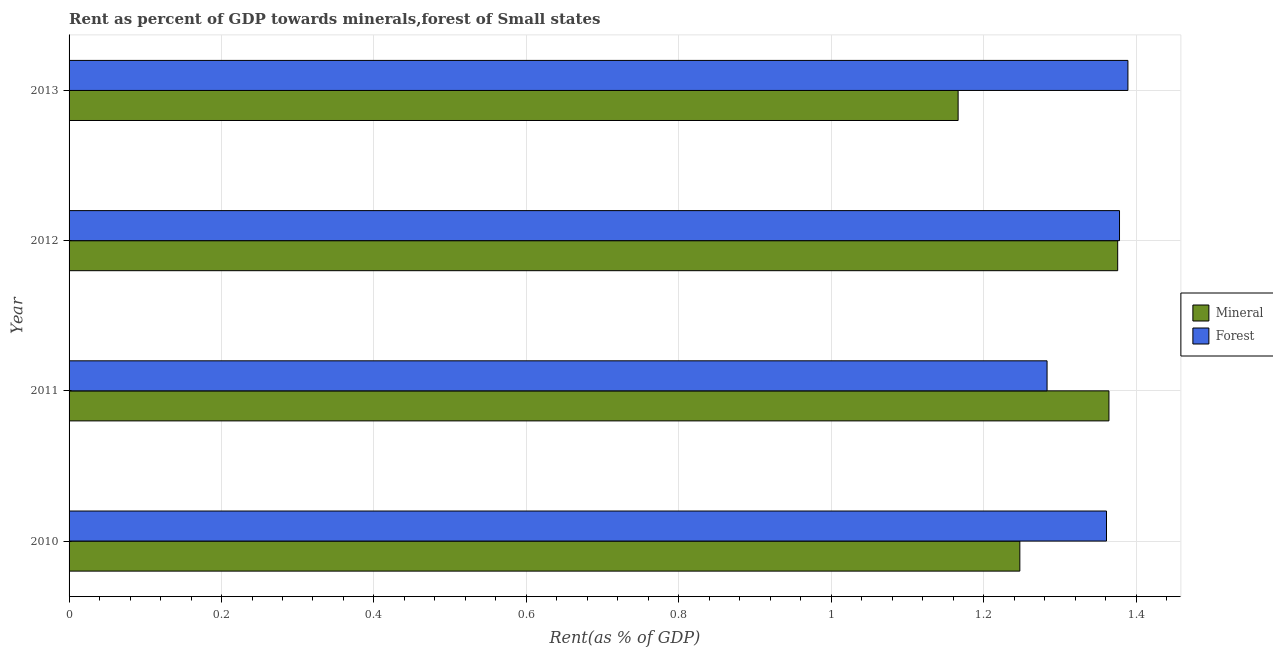How many different coloured bars are there?
Provide a succinct answer. 2. Are the number of bars per tick equal to the number of legend labels?
Your answer should be very brief. Yes. Are the number of bars on each tick of the Y-axis equal?
Ensure brevity in your answer.  Yes. How many bars are there on the 3rd tick from the top?
Your answer should be compact. 2. How many bars are there on the 1st tick from the bottom?
Your answer should be very brief. 2. In how many cases, is the number of bars for a given year not equal to the number of legend labels?
Make the answer very short. 0. What is the forest rent in 2013?
Keep it short and to the point. 1.39. Across all years, what is the maximum mineral rent?
Your answer should be compact. 1.38. Across all years, what is the minimum forest rent?
Ensure brevity in your answer.  1.28. In which year was the mineral rent maximum?
Your response must be concise. 2012. In which year was the forest rent minimum?
Keep it short and to the point. 2011. What is the total mineral rent in the graph?
Keep it short and to the point. 5.15. What is the difference between the mineral rent in 2010 and that in 2012?
Offer a terse response. -0.13. What is the difference between the forest rent in 2011 and the mineral rent in 2010?
Your answer should be compact. 0.04. What is the average forest rent per year?
Offer a terse response. 1.35. In the year 2010, what is the difference between the forest rent and mineral rent?
Keep it short and to the point. 0.11. Is the forest rent in 2010 less than that in 2012?
Provide a succinct answer. Yes. What is the difference between the highest and the second highest mineral rent?
Ensure brevity in your answer.  0.01. What is the difference between the highest and the lowest forest rent?
Make the answer very short. 0.11. What does the 1st bar from the top in 2010 represents?
Your answer should be compact. Forest. What does the 2nd bar from the bottom in 2012 represents?
Offer a very short reply. Forest. Are all the bars in the graph horizontal?
Give a very brief answer. Yes. How many years are there in the graph?
Your response must be concise. 4. Does the graph contain any zero values?
Give a very brief answer. No. Does the graph contain grids?
Make the answer very short. Yes. Where does the legend appear in the graph?
Provide a short and direct response. Center right. How many legend labels are there?
Provide a succinct answer. 2. What is the title of the graph?
Make the answer very short. Rent as percent of GDP towards minerals,forest of Small states. Does "Females" appear as one of the legend labels in the graph?
Your response must be concise. No. What is the label or title of the X-axis?
Offer a terse response. Rent(as % of GDP). What is the Rent(as % of GDP) of Mineral in 2010?
Make the answer very short. 1.25. What is the Rent(as % of GDP) of Forest in 2010?
Ensure brevity in your answer.  1.36. What is the Rent(as % of GDP) of Mineral in 2011?
Keep it short and to the point. 1.36. What is the Rent(as % of GDP) in Forest in 2011?
Your answer should be very brief. 1.28. What is the Rent(as % of GDP) in Mineral in 2012?
Make the answer very short. 1.38. What is the Rent(as % of GDP) in Forest in 2012?
Your response must be concise. 1.38. What is the Rent(as % of GDP) in Mineral in 2013?
Give a very brief answer. 1.17. What is the Rent(as % of GDP) in Forest in 2013?
Your answer should be very brief. 1.39. Across all years, what is the maximum Rent(as % of GDP) in Mineral?
Provide a succinct answer. 1.38. Across all years, what is the maximum Rent(as % of GDP) in Forest?
Your response must be concise. 1.39. Across all years, what is the minimum Rent(as % of GDP) of Mineral?
Keep it short and to the point. 1.17. Across all years, what is the minimum Rent(as % of GDP) of Forest?
Offer a very short reply. 1.28. What is the total Rent(as % of GDP) in Mineral in the graph?
Offer a very short reply. 5.15. What is the total Rent(as % of GDP) of Forest in the graph?
Give a very brief answer. 5.41. What is the difference between the Rent(as % of GDP) in Mineral in 2010 and that in 2011?
Offer a terse response. -0.12. What is the difference between the Rent(as % of GDP) of Forest in 2010 and that in 2011?
Your response must be concise. 0.08. What is the difference between the Rent(as % of GDP) of Mineral in 2010 and that in 2012?
Ensure brevity in your answer.  -0.13. What is the difference between the Rent(as % of GDP) of Forest in 2010 and that in 2012?
Give a very brief answer. -0.02. What is the difference between the Rent(as % of GDP) of Mineral in 2010 and that in 2013?
Your answer should be very brief. 0.08. What is the difference between the Rent(as % of GDP) in Forest in 2010 and that in 2013?
Keep it short and to the point. -0.03. What is the difference between the Rent(as % of GDP) in Mineral in 2011 and that in 2012?
Offer a very short reply. -0.01. What is the difference between the Rent(as % of GDP) of Forest in 2011 and that in 2012?
Provide a succinct answer. -0.1. What is the difference between the Rent(as % of GDP) of Mineral in 2011 and that in 2013?
Ensure brevity in your answer.  0.2. What is the difference between the Rent(as % of GDP) in Forest in 2011 and that in 2013?
Make the answer very short. -0.11. What is the difference between the Rent(as % of GDP) in Mineral in 2012 and that in 2013?
Make the answer very short. 0.21. What is the difference between the Rent(as % of GDP) of Forest in 2012 and that in 2013?
Make the answer very short. -0.01. What is the difference between the Rent(as % of GDP) in Mineral in 2010 and the Rent(as % of GDP) in Forest in 2011?
Provide a short and direct response. -0.04. What is the difference between the Rent(as % of GDP) in Mineral in 2010 and the Rent(as % of GDP) in Forest in 2012?
Offer a very short reply. -0.13. What is the difference between the Rent(as % of GDP) of Mineral in 2010 and the Rent(as % of GDP) of Forest in 2013?
Keep it short and to the point. -0.14. What is the difference between the Rent(as % of GDP) in Mineral in 2011 and the Rent(as % of GDP) in Forest in 2012?
Provide a succinct answer. -0.01. What is the difference between the Rent(as % of GDP) in Mineral in 2011 and the Rent(as % of GDP) in Forest in 2013?
Provide a succinct answer. -0.02. What is the difference between the Rent(as % of GDP) of Mineral in 2012 and the Rent(as % of GDP) of Forest in 2013?
Give a very brief answer. -0.01. What is the average Rent(as % of GDP) of Mineral per year?
Provide a short and direct response. 1.29. What is the average Rent(as % of GDP) in Forest per year?
Give a very brief answer. 1.35. In the year 2010, what is the difference between the Rent(as % of GDP) in Mineral and Rent(as % of GDP) in Forest?
Offer a very short reply. -0.11. In the year 2011, what is the difference between the Rent(as % of GDP) of Mineral and Rent(as % of GDP) of Forest?
Keep it short and to the point. 0.08. In the year 2012, what is the difference between the Rent(as % of GDP) of Mineral and Rent(as % of GDP) of Forest?
Offer a very short reply. -0. In the year 2013, what is the difference between the Rent(as % of GDP) of Mineral and Rent(as % of GDP) of Forest?
Make the answer very short. -0.22. What is the ratio of the Rent(as % of GDP) of Mineral in 2010 to that in 2011?
Make the answer very short. 0.91. What is the ratio of the Rent(as % of GDP) in Forest in 2010 to that in 2011?
Give a very brief answer. 1.06. What is the ratio of the Rent(as % of GDP) in Mineral in 2010 to that in 2012?
Your answer should be compact. 0.91. What is the ratio of the Rent(as % of GDP) in Forest in 2010 to that in 2012?
Make the answer very short. 0.99. What is the ratio of the Rent(as % of GDP) in Mineral in 2010 to that in 2013?
Make the answer very short. 1.07. What is the ratio of the Rent(as % of GDP) of Forest in 2010 to that in 2013?
Keep it short and to the point. 0.98. What is the ratio of the Rent(as % of GDP) in Forest in 2011 to that in 2012?
Offer a very short reply. 0.93. What is the ratio of the Rent(as % of GDP) in Mineral in 2011 to that in 2013?
Provide a short and direct response. 1.17. What is the ratio of the Rent(as % of GDP) in Forest in 2011 to that in 2013?
Your response must be concise. 0.92. What is the ratio of the Rent(as % of GDP) of Mineral in 2012 to that in 2013?
Your response must be concise. 1.18. What is the difference between the highest and the second highest Rent(as % of GDP) in Mineral?
Offer a very short reply. 0.01. What is the difference between the highest and the second highest Rent(as % of GDP) in Forest?
Offer a terse response. 0.01. What is the difference between the highest and the lowest Rent(as % of GDP) of Mineral?
Give a very brief answer. 0.21. What is the difference between the highest and the lowest Rent(as % of GDP) of Forest?
Your answer should be compact. 0.11. 